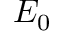<formula> <loc_0><loc_0><loc_500><loc_500>E _ { 0 }</formula> 